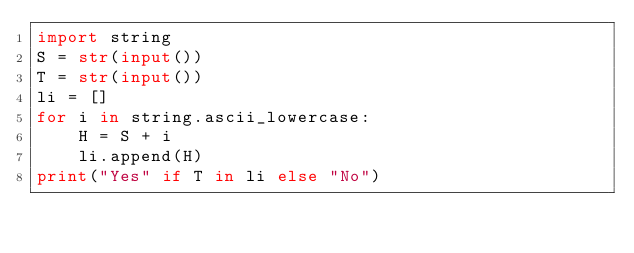<code> <loc_0><loc_0><loc_500><loc_500><_Python_>import string
S = str(input())
T = str(input())
li = []
for i in string.ascii_lowercase:
    H = S + i
    li.append(H)
print("Yes" if T in li else "No")</code> 